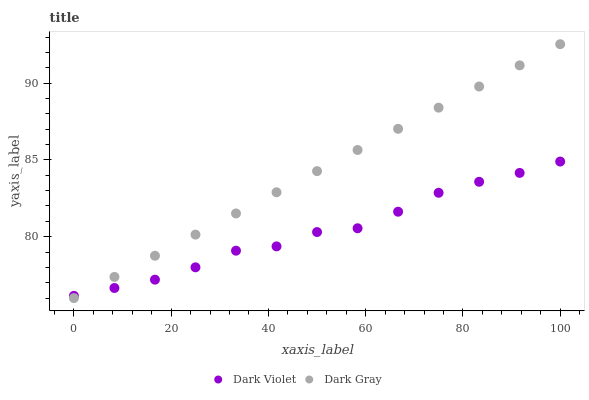Does Dark Violet have the minimum area under the curve?
Answer yes or no. Yes. Does Dark Gray have the maximum area under the curve?
Answer yes or no. Yes. Does Dark Violet have the maximum area under the curve?
Answer yes or no. No. Is Dark Gray the smoothest?
Answer yes or no. Yes. Is Dark Violet the roughest?
Answer yes or no. Yes. Is Dark Violet the smoothest?
Answer yes or no. No. Does Dark Gray have the lowest value?
Answer yes or no. Yes. Does Dark Violet have the lowest value?
Answer yes or no. No. Does Dark Gray have the highest value?
Answer yes or no. Yes. Does Dark Violet have the highest value?
Answer yes or no. No. Does Dark Gray intersect Dark Violet?
Answer yes or no. Yes. Is Dark Gray less than Dark Violet?
Answer yes or no. No. Is Dark Gray greater than Dark Violet?
Answer yes or no. No. 